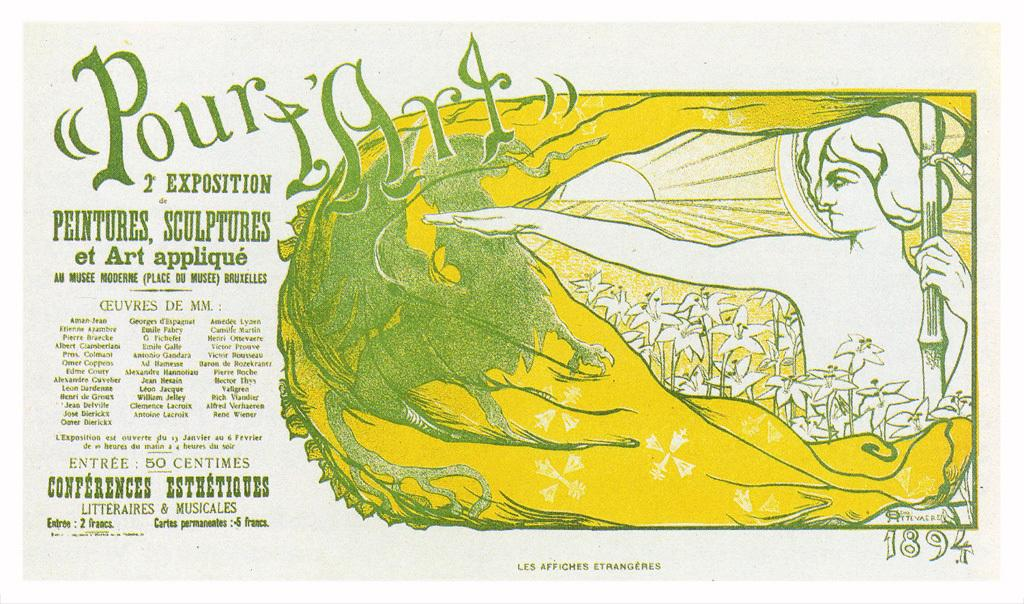<image>
Present a compact description of the photo's key features. a yellow image with the word pour on it 